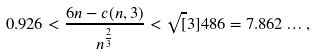Convert formula to latex. <formula><loc_0><loc_0><loc_500><loc_500>0 . 9 2 6 < \frac { 6 n - c ( n , 3 ) } { n ^ { \frac { 2 } { 3 } } } < \sqrt { [ } 3 ] { 4 8 6 } = 7 . 8 6 2 \dots ,</formula> 